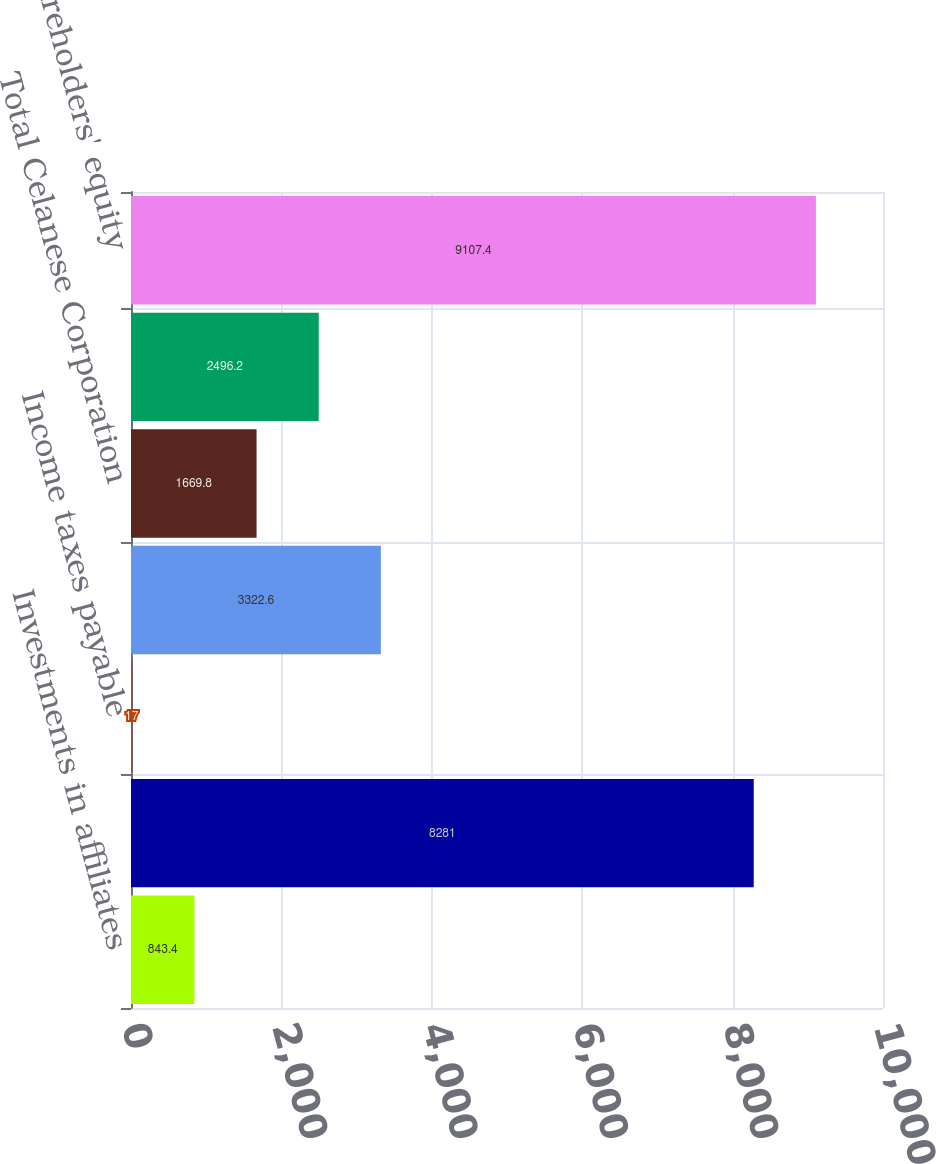<chart> <loc_0><loc_0><loc_500><loc_500><bar_chart><fcel>Investments in affiliates<fcel>Total assets<fcel>Income taxes payable<fcel>Total current liabilities<fcel>Total Celanese Corporation<fcel>Noncontrolling interests Total<fcel>shareholders' equity<nl><fcel>843.4<fcel>8281<fcel>17<fcel>3322.6<fcel>1669.8<fcel>2496.2<fcel>9107.4<nl></chart> 